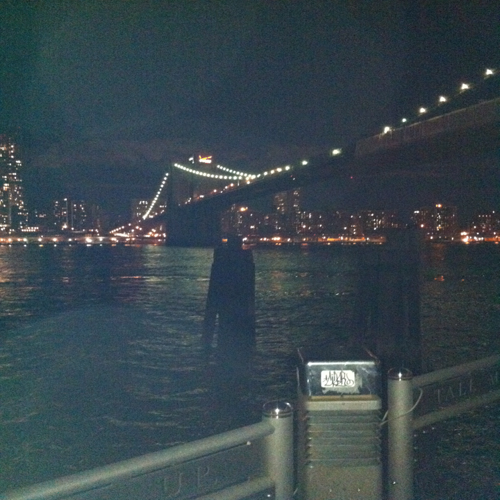Can you describe the lighting conditions in this image? The image was captured at night, as evidenced by the dark sky and the artificial lighting illuminating the bridge and the cityscape in the background. The bridge lights form a dotted line pattern, leading the eye across the bridge, while the building lights in the distance suggest a densely populated urban area. 